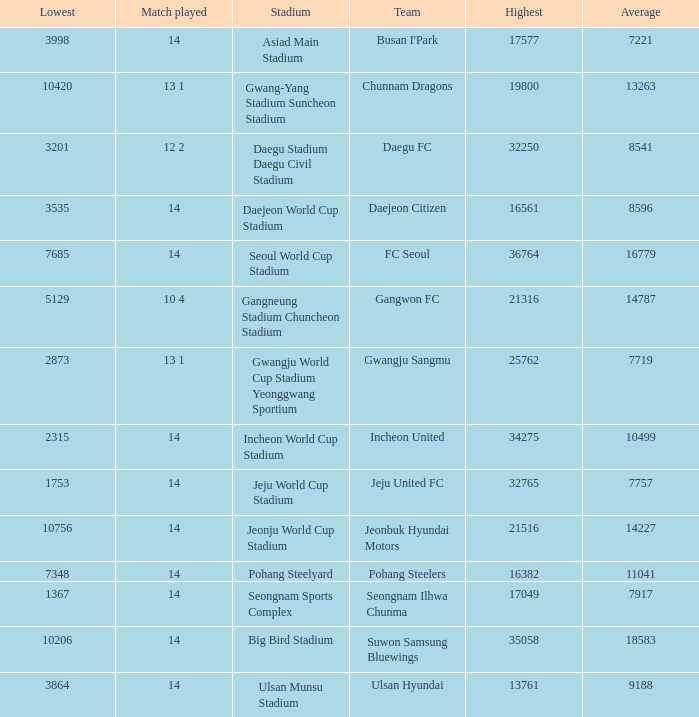Which team has 7757 as the average? Jeju United FC. 